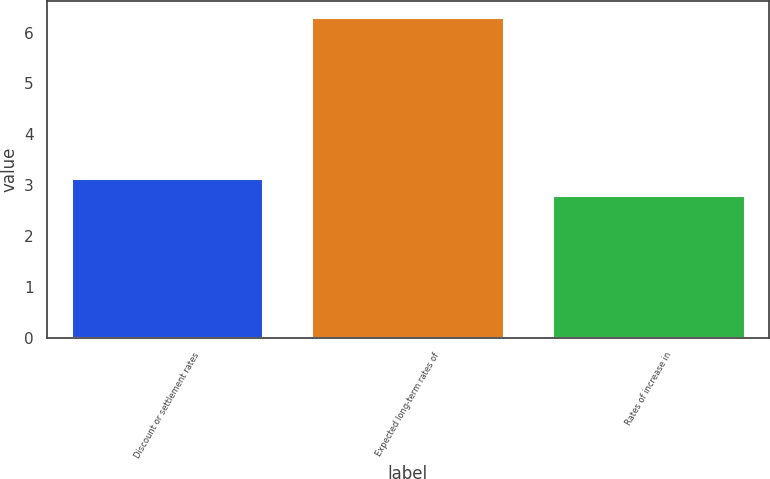Convert chart to OTSL. <chart><loc_0><loc_0><loc_500><loc_500><bar_chart><fcel>Discount or settlement rates<fcel>Expected long-term rates of<fcel>Rates of increase in<nl><fcel>3.15<fcel>6.3<fcel>2.8<nl></chart> 